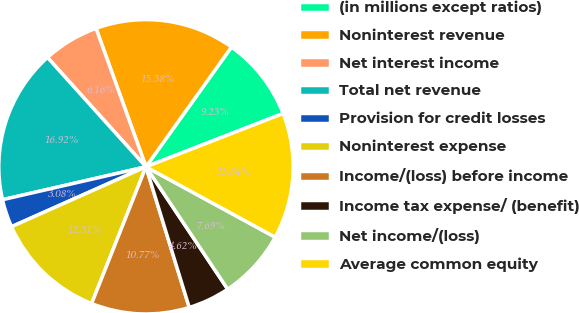Convert chart. <chart><loc_0><loc_0><loc_500><loc_500><pie_chart><fcel>(in millions except ratios)<fcel>Noninterest revenue<fcel>Net interest income<fcel>Total net revenue<fcel>Provision for credit losses<fcel>Noninterest expense<fcel>Income/(loss) before income<fcel>Income tax expense/ (benefit)<fcel>Net income/(loss)<fcel>Average common equity<nl><fcel>9.23%<fcel>15.38%<fcel>6.16%<fcel>16.92%<fcel>3.08%<fcel>12.31%<fcel>10.77%<fcel>4.62%<fcel>7.69%<fcel>13.84%<nl></chart> 